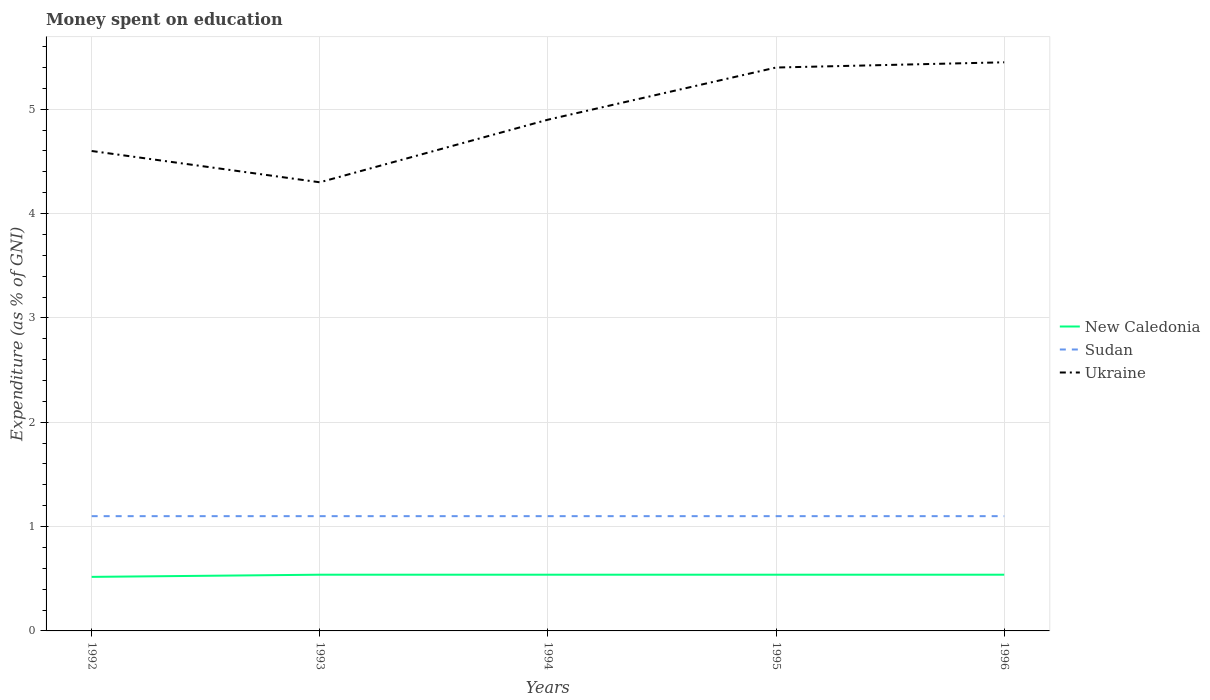How many different coloured lines are there?
Your answer should be very brief. 3. Does the line corresponding to Ukraine intersect with the line corresponding to Sudan?
Offer a very short reply. No. Across all years, what is the maximum amount of money spent on education in New Caledonia?
Ensure brevity in your answer.  0.52. In which year was the amount of money spent on education in Ukraine maximum?
Make the answer very short. 1993. What is the total amount of money spent on education in Sudan in the graph?
Keep it short and to the point. 0. What is the difference between the highest and the second highest amount of money spent on education in New Caledonia?
Keep it short and to the point. 0.02. What is the difference between the highest and the lowest amount of money spent on education in New Caledonia?
Provide a short and direct response. 4. How many years are there in the graph?
Provide a succinct answer. 5. What is the difference between two consecutive major ticks on the Y-axis?
Your response must be concise. 1. Are the values on the major ticks of Y-axis written in scientific E-notation?
Your answer should be very brief. No. Does the graph contain any zero values?
Your response must be concise. No. Where does the legend appear in the graph?
Ensure brevity in your answer.  Center right. How many legend labels are there?
Your response must be concise. 3. What is the title of the graph?
Ensure brevity in your answer.  Money spent on education. What is the label or title of the Y-axis?
Provide a short and direct response. Expenditure (as % of GNI). What is the Expenditure (as % of GNI) of New Caledonia in 1992?
Make the answer very short. 0.52. What is the Expenditure (as % of GNI) of Sudan in 1992?
Make the answer very short. 1.1. What is the Expenditure (as % of GNI) in New Caledonia in 1993?
Make the answer very short. 0.54. What is the Expenditure (as % of GNI) in Sudan in 1993?
Give a very brief answer. 1.1. What is the Expenditure (as % of GNI) in New Caledonia in 1994?
Offer a very short reply. 0.54. What is the Expenditure (as % of GNI) in Sudan in 1994?
Your answer should be compact. 1.1. What is the Expenditure (as % of GNI) in Ukraine in 1994?
Give a very brief answer. 4.9. What is the Expenditure (as % of GNI) in New Caledonia in 1995?
Offer a very short reply. 0.54. What is the Expenditure (as % of GNI) in Sudan in 1995?
Your answer should be very brief. 1.1. What is the Expenditure (as % of GNI) of Ukraine in 1995?
Keep it short and to the point. 5.4. What is the Expenditure (as % of GNI) of New Caledonia in 1996?
Your answer should be very brief. 0.54. What is the Expenditure (as % of GNI) of Sudan in 1996?
Ensure brevity in your answer.  1.1. What is the Expenditure (as % of GNI) in Ukraine in 1996?
Your response must be concise. 5.45. Across all years, what is the maximum Expenditure (as % of GNI) of New Caledonia?
Give a very brief answer. 0.54. Across all years, what is the maximum Expenditure (as % of GNI) in Sudan?
Give a very brief answer. 1.1. Across all years, what is the maximum Expenditure (as % of GNI) of Ukraine?
Your response must be concise. 5.45. Across all years, what is the minimum Expenditure (as % of GNI) in New Caledonia?
Offer a terse response. 0.52. Across all years, what is the minimum Expenditure (as % of GNI) of Sudan?
Keep it short and to the point. 1.1. Across all years, what is the minimum Expenditure (as % of GNI) of Ukraine?
Provide a succinct answer. 4.3. What is the total Expenditure (as % of GNI) in New Caledonia in the graph?
Your answer should be compact. 2.67. What is the total Expenditure (as % of GNI) of Ukraine in the graph?
Offer a very short reply. 24.65. What is the difference between the Expenditure (as % of GNI) in New Caledonia in 1992 and that in 1993?
Your answer should be compact. -0.02. What is the difference between the Expenditure (as % of GNI) in Sudan in 1992 and that in 1993?
Offer a terse response. 0. What is the difference between the Expenditure (as % of GNI) of Ukraine in 1992 and that in 1993?
Provide a succinct answer. 0.3. What is the difference between the Expenditure (as % of GNI) in New Caledonia in 1992 and that in 1994?
Provide a short and direct response. -0.02. What is the difference between the Expenditure (as % of GNI) in New Caledonia in 1992 and that in 1995?
Your answer should be very brief. -0.02. What is the difference between the Expenditure (as % of GNI) in New Caledonia in 1992 and that in 1996?
Make the answer very short. -0.02. What is the difference between the Expenditure (as % of GNI) in Ukraine in 1992 and that in 1996?
Offer a very short reply. -0.85. What is the difference between the Expenditure (as % of GNI) in New Caledonia in 1993 and that in 1995?
Your answer should be compact. 0. What is the difference between the Expenditure (as % of GNI) in Ukraine in 1993 and that in 1996?
Your response must be concise. -1.15. What is the difference between the Expenditure (as % of GNI) of New Caledonia in 1994 and that in 1995?
Provide a short and direct response. 0. What is the difference between the Expenditure (as % of GNI) of Sudan in 1994 and that in 1995?
Offer a terse response. 0. What is the difference between the Expenditure (as % of GNI) of Sudan in 1994 and that in 1996?
Your answer should be compact. 0. What is the difference between the Expenditure (as % of GNI) of Ukraine in 1994 and that in 1996?
Your response must be concise. -0.55. What is the difference between the Expenditure (as % of GNI) of New Caledonia in 1995 and that in 1996?
Keep it short and to the point. 0. What is the difference between the Expenditure (as % of GNI) of Ukraine in 1995 and that in 1996?
Make the answer very short. -0.05. What is the difference between the Expenditure (as % of GNI) in New Caledonia in 1992 and the Expenditure (as % of GNI) in Sudan in 1993?
Your response must be concise. -0.58. What is the difference between the Expenditure (as % of GNI) of New Caledonia in 1992 and the Expenditure (as % of GNI) of Ukraine in 1993?
Give a very brief answer. -3.78. What is the difference between the Expenditure (as % of GNI) in New Caledonia in 1992 and the Expenditure (as % of GNI) in Sudan in 1994?
Your answer should be very brief. -0.58. What is the difference between the Expenditure (as % of GNI) of New Caledonia in 1992 and the Expenditure (as % of GNI) of Ukraine in 1994?
Keep it short and to the point. -4.38. What is the difference between the Expenditure (as % of GNI) of New Caledonia in 1992 and the Expenditure (as % of GNI) of Sudan in 1995?
Your answer should be very brief. -0.58. What is the difference between the Expenditure (as % of GNI) in New Caledonia in 1992 and the Expenditure (as % of GNI) in Ukraine in 1995?
Offer a terse response. -4.88. What is the difference between the Expenditure (as % of GNI) in Sudan in 1992 and the Expenditure (as % of GNI) in Ukraine in 1995?
Provide a succinct answer. -4.3. What is the difference between the Expenditure (as % of GNI) in New Caledonia in 1992 and the Expenditure (as % of GNI) in Sudan in 1996?
Give a very brief answer. -0.58. What is the difference between the Expenditure (as % of GNI) of New Caledonia in 1992 and the Expenditure (as % of GNI) of Ukraine in 1996?
Your answer should be very brief. -4.93. What is the difference between the Expenditure (as % of GNI) in Sudan in 1992 and the Expenditure (as % of GNI) in Ukraine in 1996?
Provide a short and direct response. -4.35. What is the difference between the Expenditure (as % of GNI) of New Caledonia in 1993 and the Expenditure (as % of GNI) of Sudan in 1994?
Offer a terse response. -0.56. What is the difference between the Expenditure (as % of GNI) of New Caledonia in 1993 and the Expenditure (as % of GNI) of Ukraine in 1994?
Offer a very short reply. -4.36. What is the difference between the Expenditure (as % of GNI) of New Caledonia in 1993 and the Expenditure (as % of GNI) of Sudan in 1995?
Keep it short and to the point. -0.56. What is the difference between the Expenditure (as % of GNI) in New Caledonia in 1993 and the Expenditure (as % of GNI) in Ukraine in 1995?
Offer a very short reply. -4.86. What is the difference between the Expenditure (as % of GNI) in Sudan in 1993 and the Expenditure (as % of GNI) in Ukraine in 1995?
Provide a short and direct response. -4.3. What is the difference between the Expenditure (as % of GNI) in New Caledonia in 1993 and the Expenditure (as % of GNI) in Sudan in 1996?
Provide a short and direct response. -0.56. What is the difference between the Expenditure (as % of GNI) in New Caledonia in 1993 and the Expenditure (as % of GNI) in Ukraine in 1996?
Provide a succinct answer. -4.91. What is the difference between the Expenditure (as % of GNI) in Sudan in 1993 and the Expenditure (as % of GNI) in Ukraine in 1996?
Keep it short and to the point. -4.35. What is the difference between the Expenditure (as % of GNI) in New Caledonia in 1994 and the Expenditure (as % of GNI) in Sudan in 1995?
Your answer should be compact. -0.56. What is the difference between the Expenditure (as % of GNI) of New Caledonia in 1994 and the Expenditure (as % of GNI) of Ukraine in 1995?
Keep it short and to the point. -4.86. What is the difference between the Expenditure (as % of GNI) in Sudan in 1994 and the Expenditure (as % of GNI) in Ukraine in 1995?
Keep it short and to the point. -4.3. What is the difference between the Expenditure (as % of GNI) of New Caledonia in 1994 and the Expenditure (as % of GNI) of Sudan in 1996?
Keep it short and to the point. -0.56. What is the difference between the Expenditure (as % of GNI) in New Caledonia in 1994 and the Expenditure (as % of GNI) in Ukraine in 1996?
Provide a short and direct response. -4.91. What is the difference between the Expenditure (as % of GNI) in Sudan in 1994 and the Expenditure (as % of GNI) in Ukraine in 1996?
Your response must be concise. -4.35. What is the difference between the Expenditure (as % of GNI) in New Caledonia in 1995 and the Expenditure (as % of GNI) in Sudan in 1996?
Your answer should be very brief. -0.56. What is the difference between the Expenditure (as % of GNI) in New Caledonia in 1995 and the Expenditure (as % of GNI) in Ukraine in 1996?
Keep it short and to the point. -4.91. What is the difference between the Expenditure (as % of GNI) of Sudan in 1995 and the Expenditure (as % of GNI) of Ukraine in 1996?
Make the answer very short. -4.35. What is the average Expenditure (as % of GNI) of New Caledonia per year?
Offer a terse response. 0.53. What is the average Expenditure (as % of GNI) of Ukraine per year?
Offer a terse response. 4.93. In the year 1992, what is the difference between the Expenditure (as % of GNI) of New Caledonia and Expenditure (as % of GNI) of Sudan?
Keep it short and to the point. -0.58. In the year 1992, what is the difference between the Expenditure (as % of GNI) of New Caledonia and Expenditure (as % of GNI) of Ukraine?
Keep it short and to the point. -4.08. In the year 1993, what is the difference between the Expenditure (as % of GNI) in New Caledonia and Expenditure (as % of GNI) in Sudan?
Ensure brevity in your answer.  -0.56. In the year 1993, what is the difference between the Expenditure (as % of GNI) of New Caledonia and Expenditure (as % of GNI) of Ukraine?
Your answer should be compact. -3.76. In the year 1993, what is the difference between the Expenditure (as % of GNI) in Sudan and Expenditure (as % of GNI) in Ukraine?
Provide a short and direct response. -3.2. In the year 1994, what is the difference between the Expenditure (as % of GNI) of New Caledonia and Expenditure (as % of GNI) of Sudan?
Provide a succinct answer. -0.56. In the year 1994, what is the difference between the Expenditure (as % of GNI) in New Caledonia and Expenditure (as % of GNI) in Ukraine?
Offer a terse response. -4.36. In the year 1994, what is the difference between the Expenditure (as % of GNI) in Sudan and Expenditure (as % of GNI) in Ukraine?
Provide a short and direct response. -3.8. In the year 1995, what is the difference between the Expenditure (as % of GNI) in New Caledonia and Expenditure (as % of GNI) in Sudan?
Your answer should be compact. -0.56. In the year 1995, what is the difference between the Expenditure (as % of GNI) of New Caledonia and Expenditure (as % of GNI) of Ukraine?
Offer a terse response. -4.86. In the year 1995, what is the difference between the Expenditure (as % of GNI) of Sudan and Expenditure (as % of GNI) of Ukraine?
Provide a succinct answer. -4.3. In the year 1996, what is the difference between the Expenditure (as % of GNI) in New Caledonia and Expenditure (as % of GNI) in Sudan?
Provide a succinct answer. -0.56. In the year 1996, what is the difference between the Expenditure (as % of GNI) of New Caledonia and Expenditure (as % of GNI) of Ukraine?
Offer a terse response. -4.91. In the year 1996, what is the difference between the Expenditure (as % of GNI) in Sudan and Expenditure (as % of GNI) in Ukraine?
Make the answer very short. -4.35. What is the ratio of the Expenditure (as % of GNI) of New Caledonia in 1992 to that in 1993?
Make the answer very short. 0.96. What is the ratio of the Expenditure (as % of GNI) in Ukraine in 1992 to that in 1993?
Provide a succinct answer. 1.07. What is the ratio of the Expenditure (as % of GNI) in New Caledonia in 1992 to that in 1994?
Make the answer very short. 0.96. What is the ratio of the Expenditure (as % of GNI) in Ukraine in 1992 to that in 1994?
Offer a terse response. 0.94. What is the ratio of the Expenditure (as % of GNI) in New Caledonia in 1992 to that in 1995?
Make the answer very short. 0.96. What is the ratio of the Expenditure (as % of GNI) in Sudan in 1992 to that in 1995?
Provide a succinct answer. 1. What is the ratio of the Expenditure (as % of GNI) of Ukraine in 1992 to that in 1995?
Make the answer very short. 0.85. What is the ratio of the Expenditure (as % of GNI) of New Caledonia in 1992 to that in 1996?
Ensure brevity in your answer.  0.96. What is the ratio of the Expenditure (as % of GNI) in Ukraine in 1992 to that in 1996?
Make the answer very short. 0.84. What is the ratio of the Expenditure (as % of GNI) in Ukraine in 1993 to that in 1994?
Give a very brief answer. 0.88. What is the ratio of the Expenditure (as % of GNI) in New Caledonia in 1993 to that in 1995?
Make the answer very short. 1. What is the ratio of the Expenditure (as % of GNI) in Ukraine in 1993 to that in 1995?
Your response must be concise. 0.8. What is the ratio of the Expenditure (as % of GNI) in New Caledonia in 1993 to that in 1996?
Offer a terse response. 1. What is the ratio of the Expenditure (as % of GNI) in Ukraine in 1993 to that in 1996?
Offer a terse response. 0.79. What is the ratio of the Expenditure (as % of GNI) in New Caledonia in 1994 to that in 1995?
Your response must be concise. 1. What is the ratio of the Expenditure (as % of GNI) in Ukraine in 1994 to that in 1995?
Ensure brevity in your answer.  0.91. What is the ratio of the Expenditure (as % of GNI) of New Caledonia in 1994 to that in 1996?
Provide a succinct answer. 1. What is the ratio of the Expenditure (as % of GNI) in Sudan in 1994 to that in 1996?
Keep it short and to the point. 1. What is the ratio of the Expenditure (as % of GNI) of Ukraine in 1994 to that in 1996?
Your response must be concise. 0.9. What is the ratio of the Expenditure (as % of GNI) in New Caledonia in 1995 to that in 1996?
Keep it short and to the point. 1. What is the ratio of the Expenditure (as % of GNI) in Ukraine in 1995 to that in 1996?
Make the answer very short. 0.99. What is the difference between the highest and the second highest Expenditure (as % of GNI) of Ukraine?
Keep it short and to the point. 0.05. What is the difference between the highest and the lowest Expenditure (as % of GNI) in New Caledonia?
Provide a short and direct response. 0.02. What is the difference between the highest and the lowest Expenditure (as % of GNI) in Ukraine?
Provide a short and direct response. 1.15. 